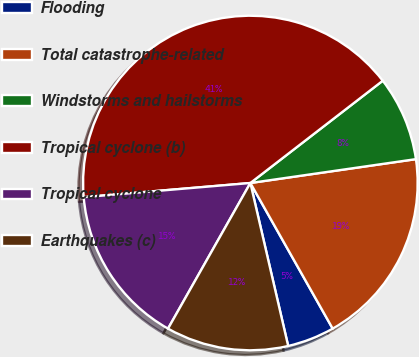Convert chart to OTSL. <chart><loc_0><loc_0><loc_500><loc_500><pie_chart><fcel>Flooding<fcel>Total catastrophe-related<fcel>Windstorms and hailstorms<fcel>Tropical cyclone (b)<fcel>Tropical cyclone<fcel>Earthquakes (c)<nl><fcel>4.56%<fcel>19.09%<fcel>8.19%<fcel>40.88%<fcel>15.46%<fcel>11.82%<nl></chart> 